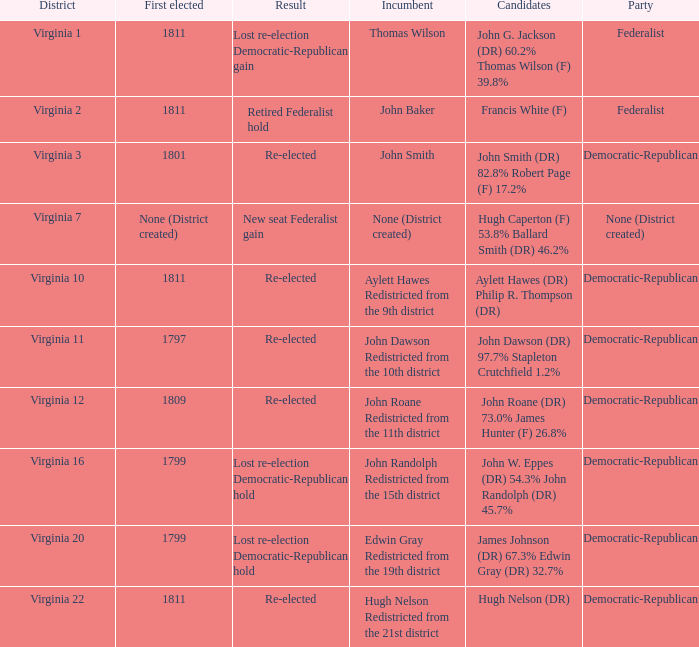Name the party for virginia 12 Democratic-Republican. 